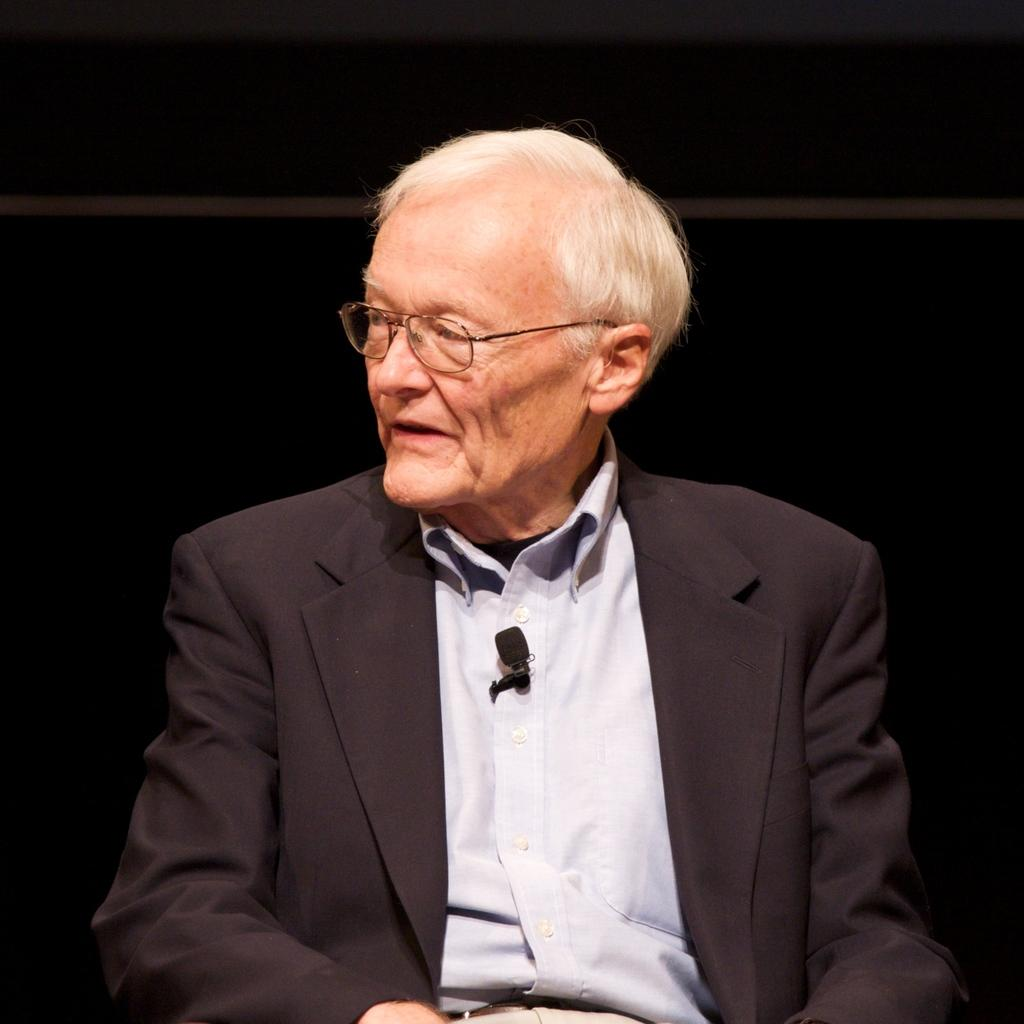Who is present in the image? There is a man in the image. What accessory is the man wearing? The man is wearing spectacles. What can be observed about the background of the image? The background of the image is dark. How many children are playing with rabbits in the image? There are no children or rabbits present in the image; it features a man wearing spectacles against a dark background. What type of rake is being used by the man in the image? There is no rake present in the image; the man is wearing spectacles and standing against a dark background. 